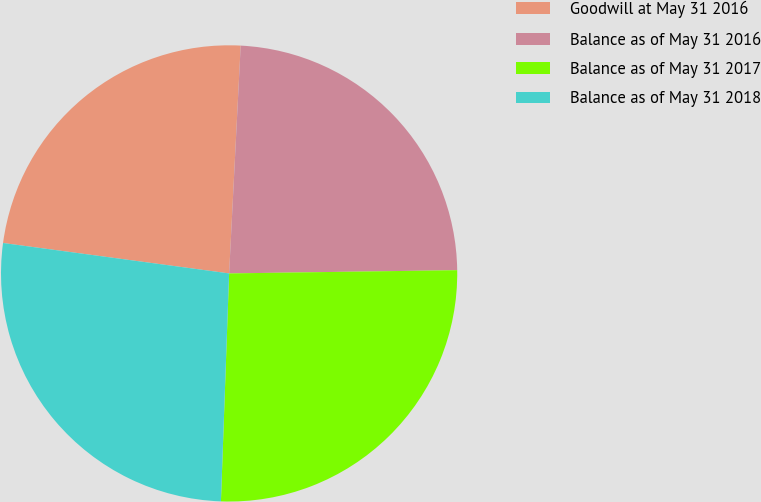<chart> <loc_0><loc_0><loc_500><loc_500><pie_chart><fcel>Goodwill at May 31 2016<fcel>Balance as of May 31 2016<fcel>Balance as of May 31 2017<fcel>Balance as of May 31 2018<nl><fcel>23.68%<fcel>23.97%<fcel>25.8%<fcel>26.56%<nl></chart> 